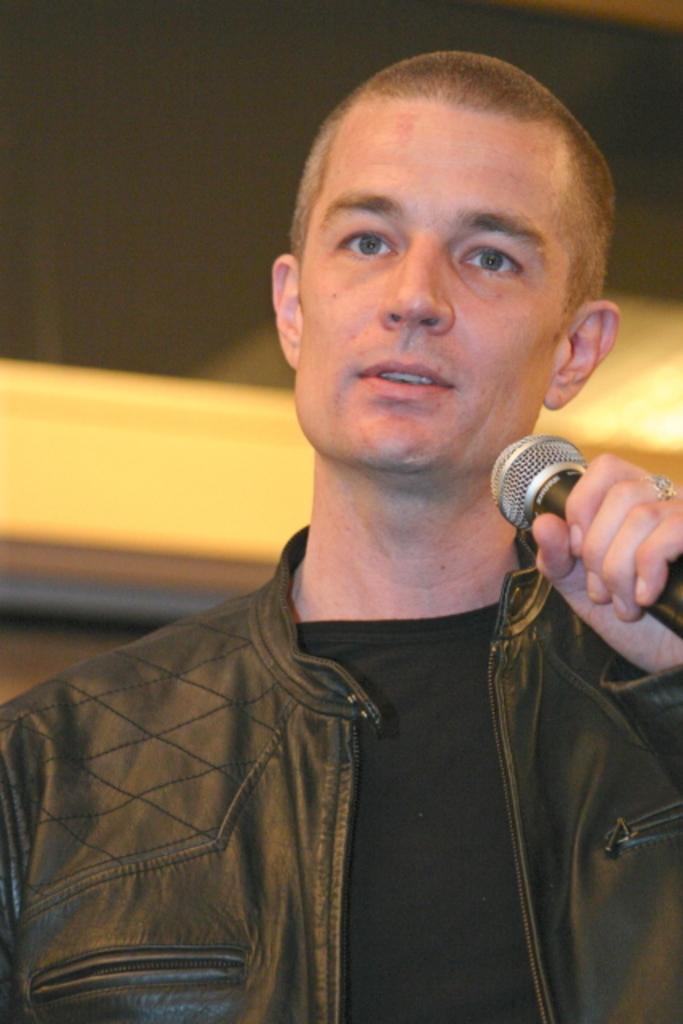In one or two sentences, can you explain what this image depicts? In this picture we can see a man is holding a microphone, he is wearing a jacket, there is a blurry background. 